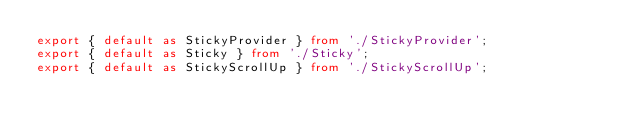<code> <loc_0><loc_0><loc_500><loc_500><_TypeScript_>export { default as StickyProvider } from './StickyProvider';
export { default as Sticky } from './Sticky';
export { default as StickyScrollUp } from './StickyScrollUp';
</code> 